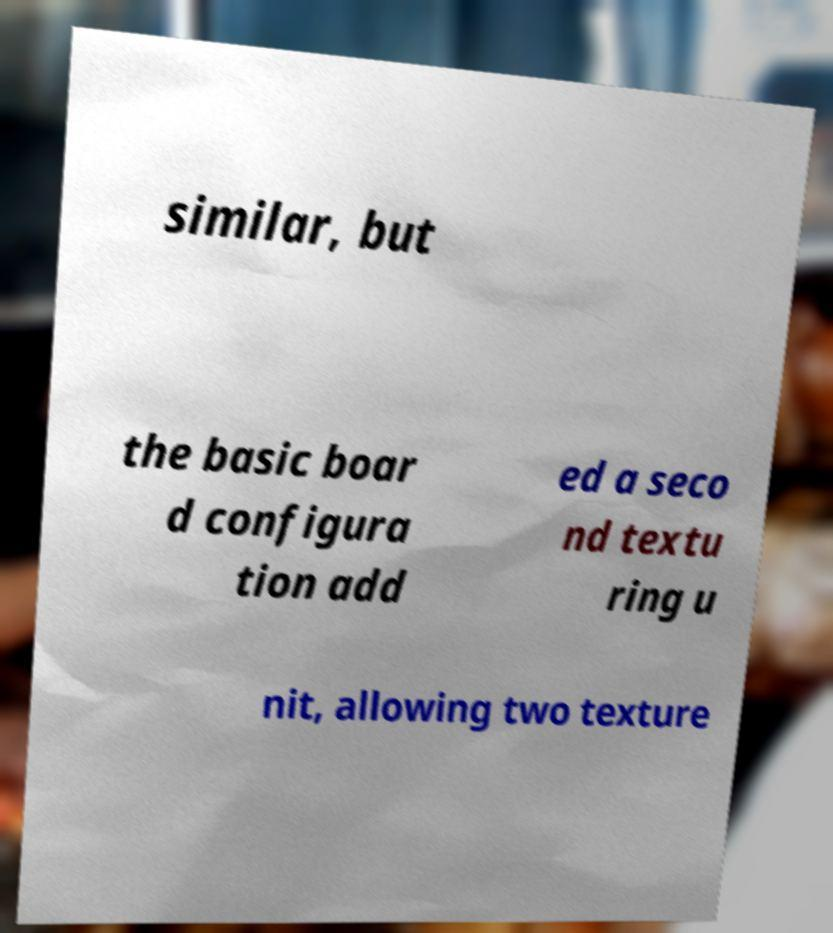Could you extract and type out the text from this image? similar, but the basic boar d configura tion add ed a seco nd textu ring u nit, allowing two texture 